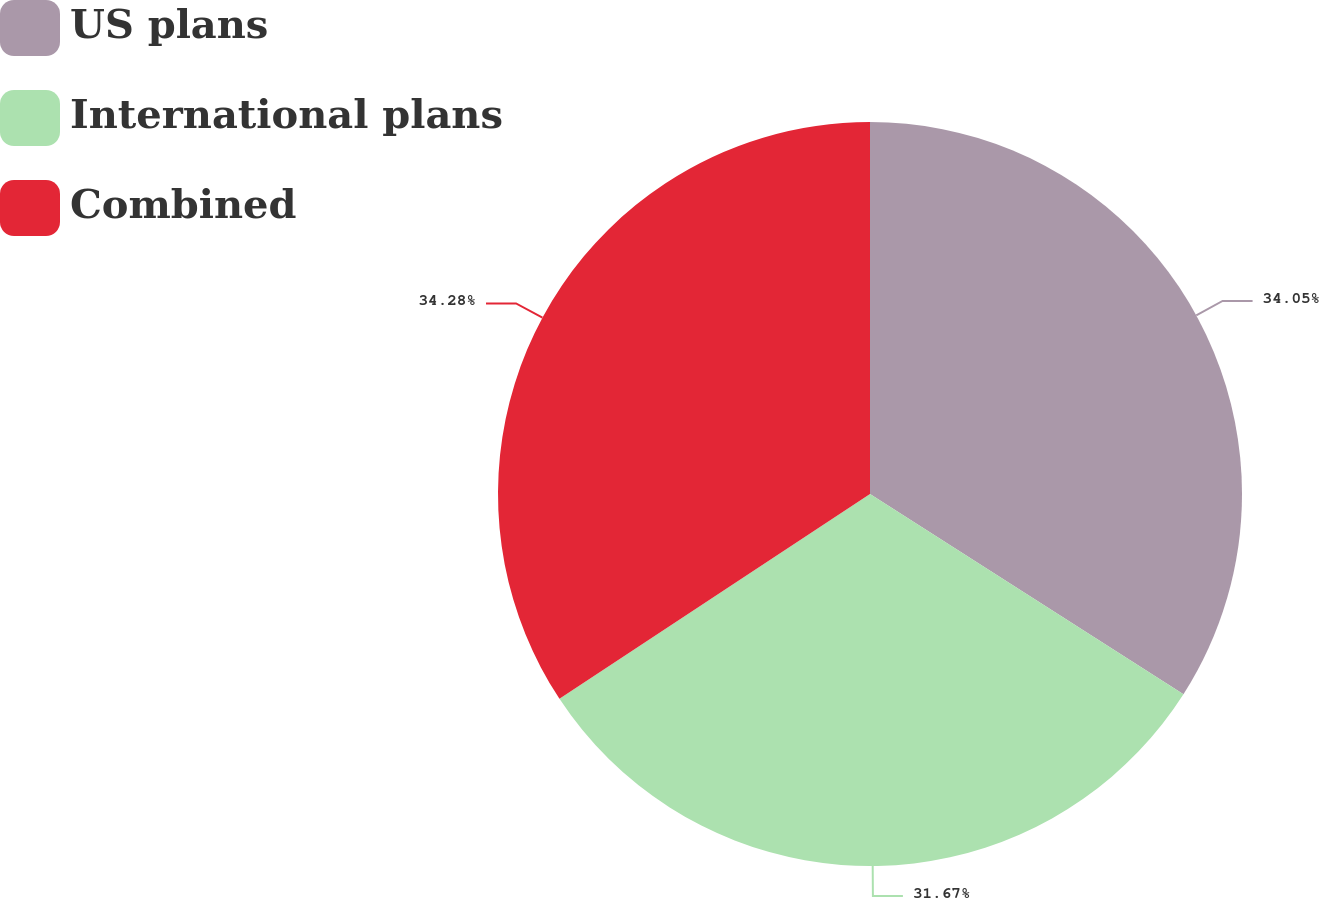Convert chart. <chart><loc_0><loc_0><loc_500><loc_500><pie_chart><fcel>US plans<fcel>International plans<fcel>Combined<nl><fcel>34.05%<fcel>31.67%<fcel>34.28%<nl></chart> 